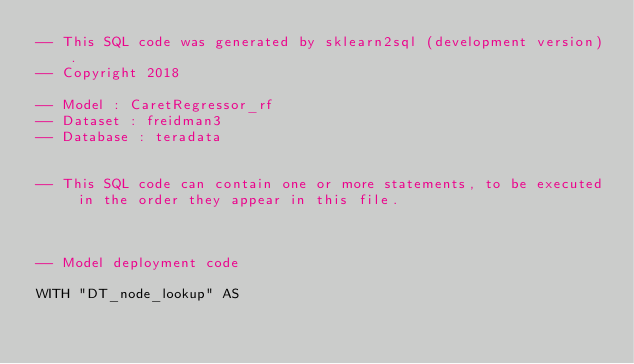Convert code to text. <code><loc_0><loc_0><loc_500><loc_500><_SQL_>-- This SQL code was generated by sklearn2sql (development version).
-- Copyright 2018

-- Model : CaretRegressor_rf
-- Dataset : freidman3
-- Database : teradata


-- This SQL code can contain one or more statements, to be executed in the order they appear in this file.



-- Model deployment code

WITH "DT_node_lookup" AS </code> 